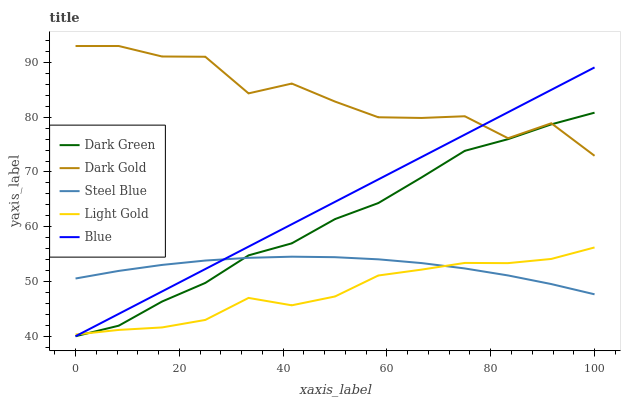Does Dark Gold have the minimum area under the curve?
Answer yes or no. No. Does Light Gold have the maximum area under the curve?
Answer yes or no. No. Is Light Gold the smoothest?
Answer yes or no. No. Is Light Gold the roughest?
Answer yes or no. No. Does Light Gold have the lowest value?
Answer yes or no. No. Does Light Gold have the highest value?
Answer yes or no. No. Is Light Gold less than Dark Gold?
Answer yes or no. Yes. Is Dark Gold greater than Light Gold?
Answer yes or no. Yes. Does Light Gold intersect Dark Gold?
Answer yes or no. No. 